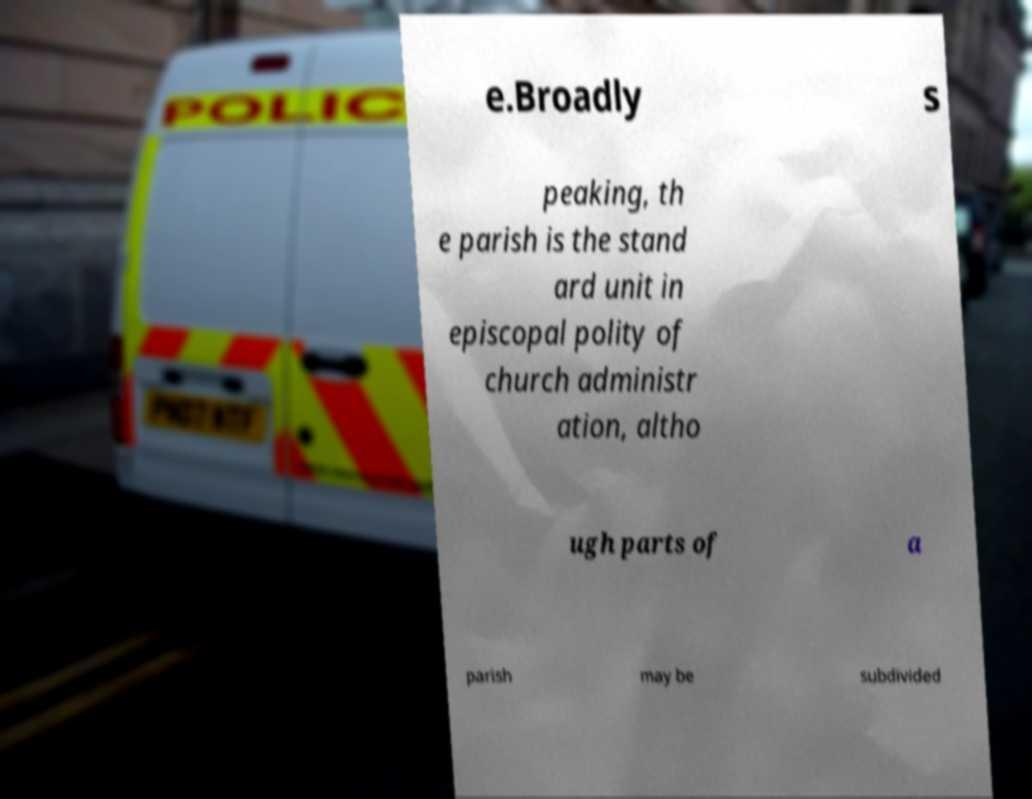There's text embedded in this image that I need extracted. Can you transcribe it verbatim? e.Broadly s peaking, th e parish is the stand ard unit in episcopal polity of church administr ation, altho ugh parts of a parish may be subdivided 